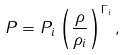<formula> <loc_0><loc_0><loc_500><loc_500>P = P _ { i } \left ( \frac { \rho } { \rho _ { i } } \right ) ^ { \Gamma _ { i } } ,</formula> 